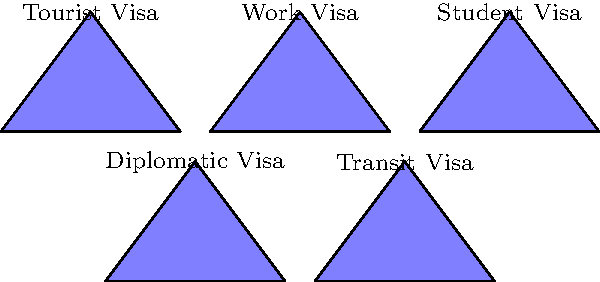Given the images of passport stamps representing different types of visas, which visa type would be most relevant for a foreign diplomat attending an international conference in the host country? To answer this question, we need to consider the nature of diplomatic work and the purpose of different visa types:

1. Tourist Visa: Intended for short-term leisure visits, not suitable for official diplomatic work.
2. Work Visa: Used for regular employment in the host country, not typically applicable for diplomatic missions.
3. Student Visa: Designed for individuals pursuing education, not relevant for diplomatic activities.
4. Diplomatic Visa: Specifically created for foreign government officials and diplomats on official business.
5. Transit Visa: Used for brief stopovers while traveling through a country, not appropriate for attending conferences.

Given that the scenario involves a foreign diplomat attending an international conference, which is an official diplomatic activity, the most appropriate visa type would be the Diplomatic Visa. This visa type is specifically designed to facilitate the entry and stay of foreign government representatives engaged in official duties, such as attending international conferences.

Diplomatic visas often come with certain privileges and immunities as outlined in the Vienna Convention on Diplomatic Relations, which is a key component of international law governing diplomatic practices.
Answer: Diplomatic Visa 